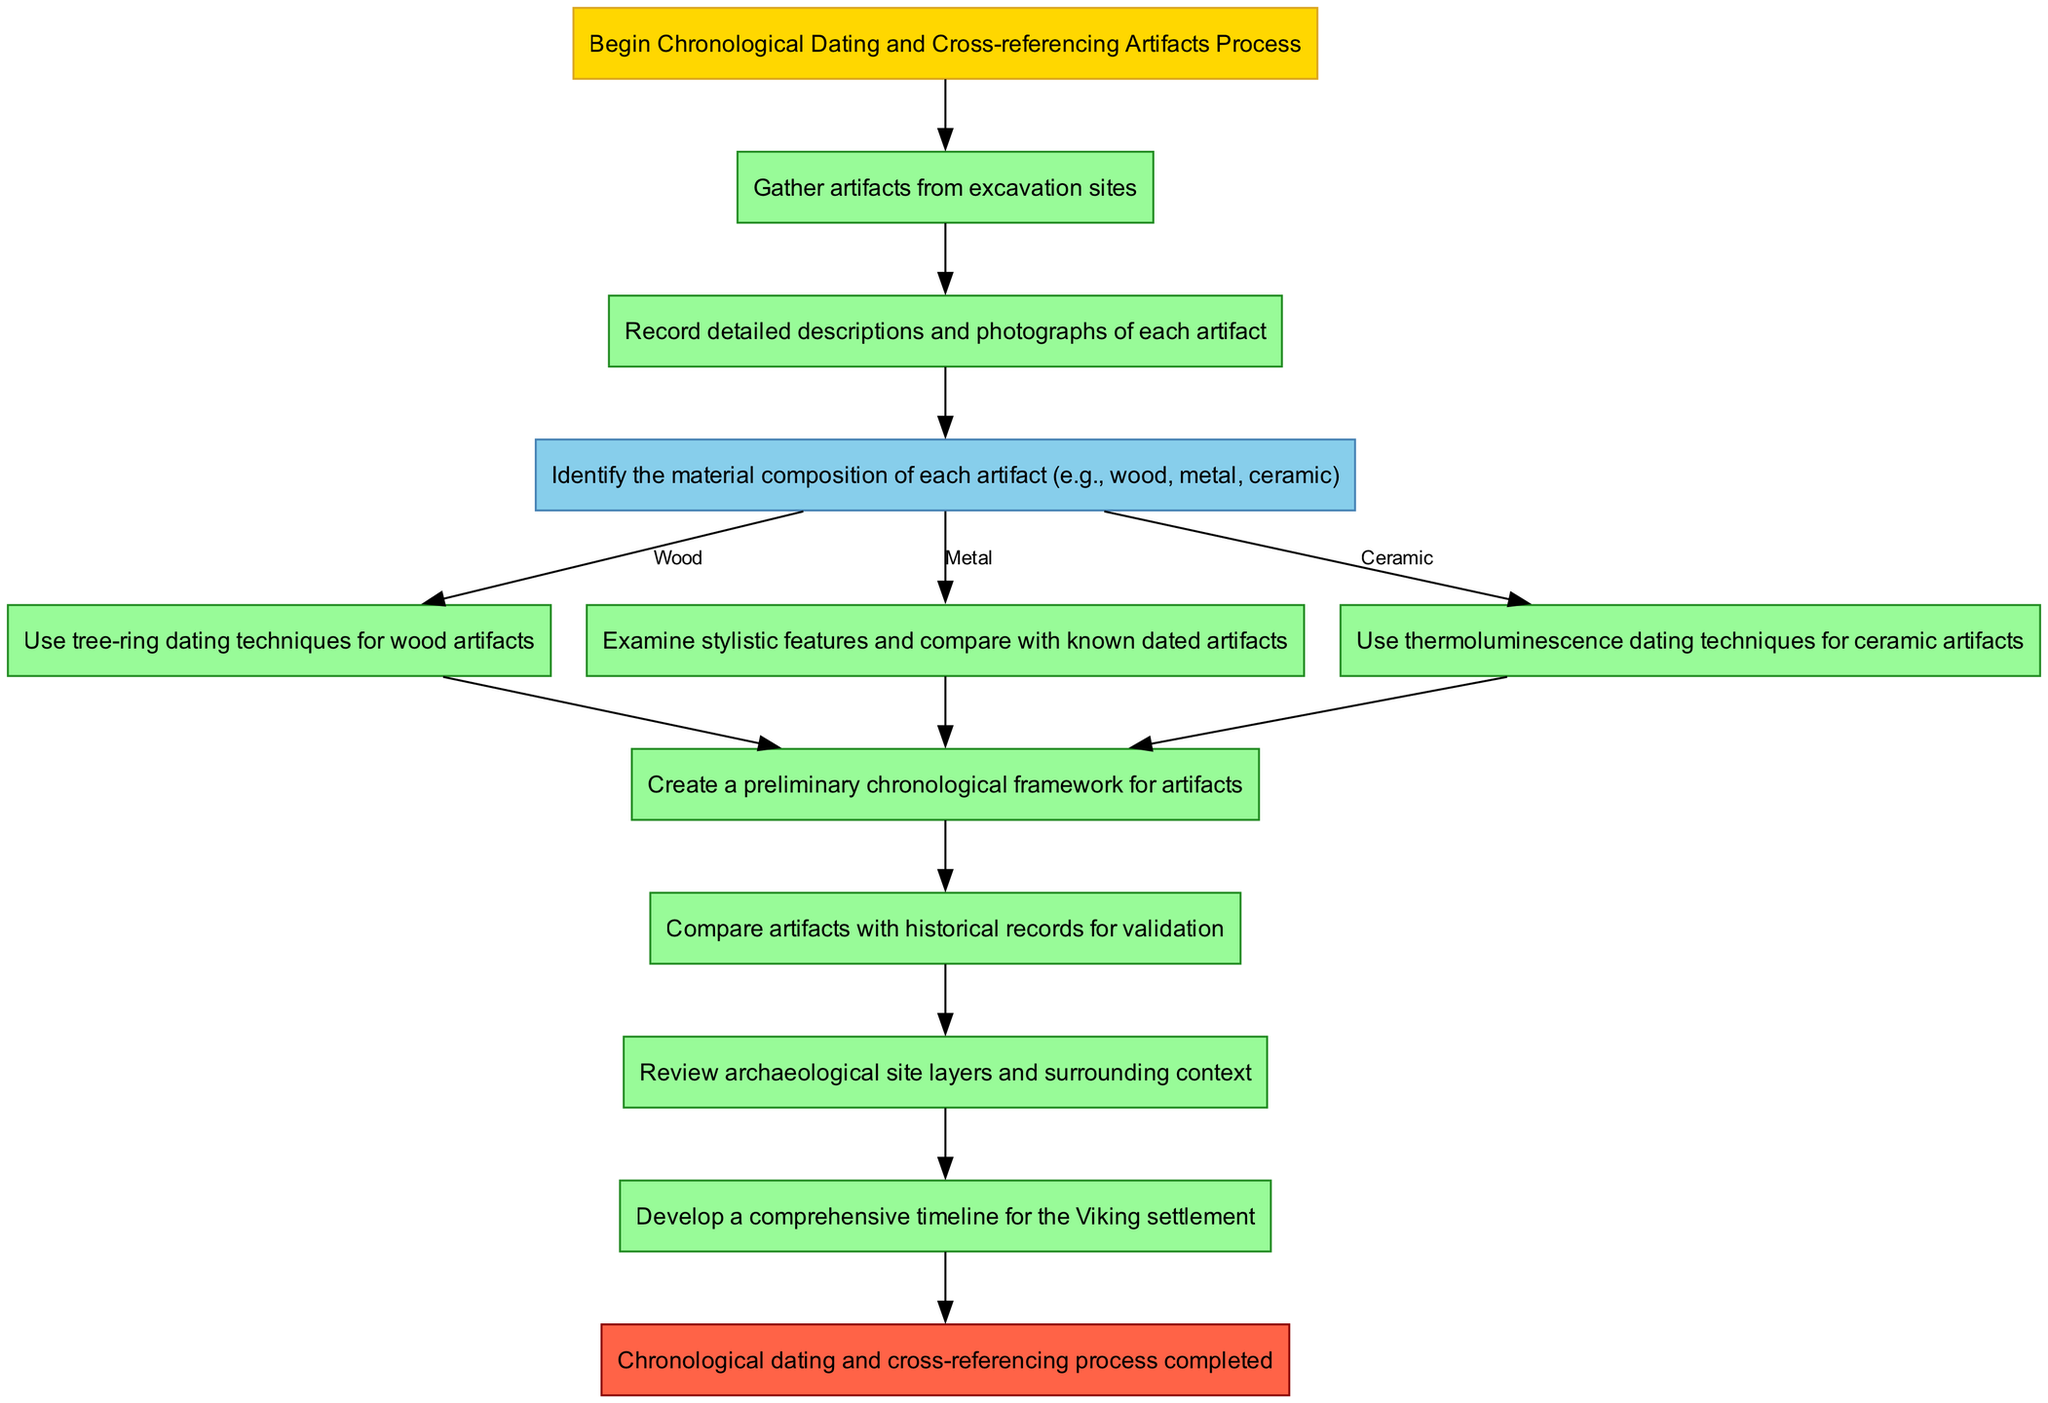What is the starting point of the process? The starting point of the process is labeled as "Start" in the diagram which begins with the description "Begin Chronological Dating and Cross-referencing Artifacts Process".
Answer: Start How many main elements are there in the process? There are ten main elements in the process as listed in the diagram, including the Start and End nodes.
Answer: 10 What is the next step after "DocumentArtifacts"? The next step after "DocumentArtifacts" is "DetermineMaterial" as indicated by the connection from "DocumentArtifacts".
Answer: DetermineMaterial What technique is used for wood artifacts? The technique used for wood artifacts is "Dendrochronology" as shown in the flowchart under the materials' options for wood.
Answer: Dendrochronology Which artifact material is compared with known dated artifacts? The artifact material that is compared with known dated artifacts is "Metal", as identified in the flowchart where "CompareStylisticFeatures" follows the identification of Metal.
Answer: Metal What comes after "GenerateChronologicalData"? The step that follows "GenerateChronologicalData" is "CrossReferenceHistoricalRecords", indicating that the chronological data will then be compared with historical records for validation.
Answer: CrossReferenceHistoricalRecords What is the final output of the process? The final output of the process is represented by the "End" node, which states that the chronological dating and cross-referencing process has been completed.
Answer: End What evidence is analyzed after cross-referencing historical records? The evidence analyzed after cross-referencing historical records is "Contextual Evidence", specifically the review of archaeological site layers and surrounding context.
Answer: Contextual Evidence What is the purpose of the "GenerateTimeline" step? The purpose of the "GenerateTimeline" step is to develop a comprehensive timeline for the Viking settlement, summarizing the chronological framework created in earlier steps of the process.
Answer: GenerateTimeline 